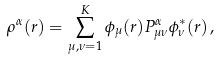<formula> <loc_0><loc_0><loc_500><loc_500>\rho ^ { \alpha } ( { r } ) = \sum _ { \mu , \nu = 1 } ^ { K } \phi _ { \mu } ( { r } ) P _ { \mu \nu } ^ { \alpha } \phi _ { \nu } ^ { * } ( { r } ) \, ,</formula> 